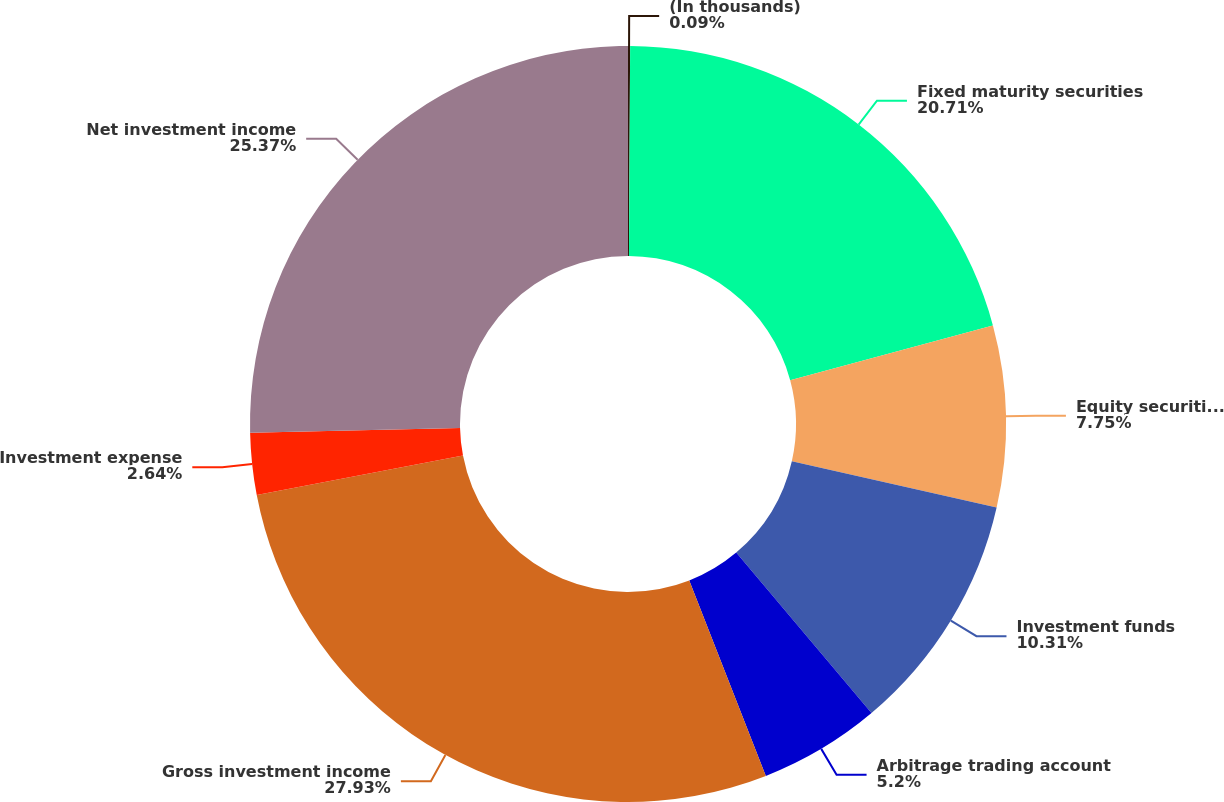Convert chart to OTSL. <chart><loc_0><loc_0><loc_500><loc_500><pie_chart><fcel>(In thousands)<fcel>Fixed maturity securities<fcel>Equity securities available<fcel>Investment funds<fcel>Arbitrage trading account<fcel>Gross investment income<fcel>Investment expense<fcel>Net investment income<nl><fcel>0.09%<fcel>20.71%<fcel>7.75%<fcel>10.31%<fcel>5.2%<fcel>27.93%<fcel>2.64%<fcel>25.37%<nl></chart> 